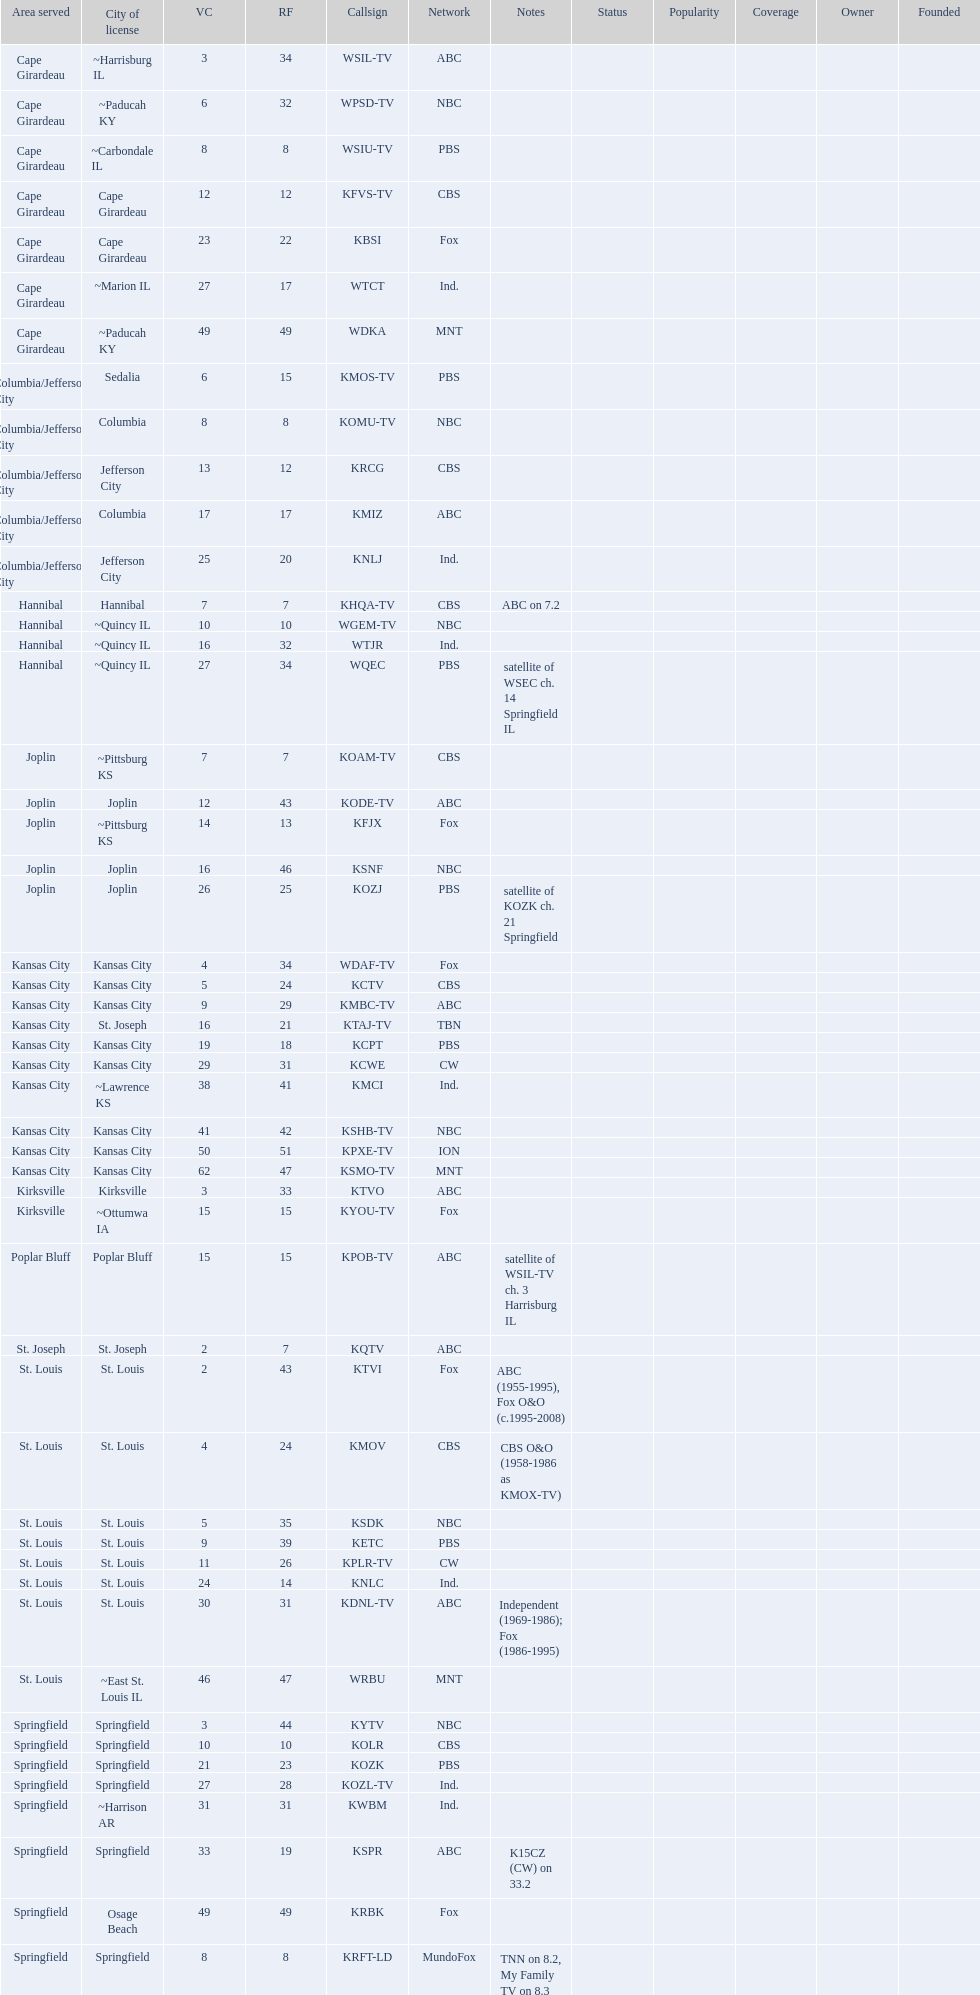Kode-tv and wsil-tv both are a part of which network? ABC. 